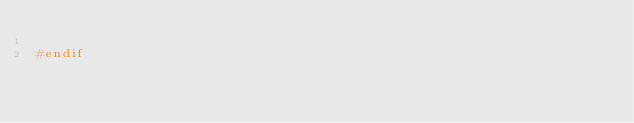Convert code to text. <code><loc_0><loc_0><loc_500><loc_500><_C++_>
#endif

</code> 